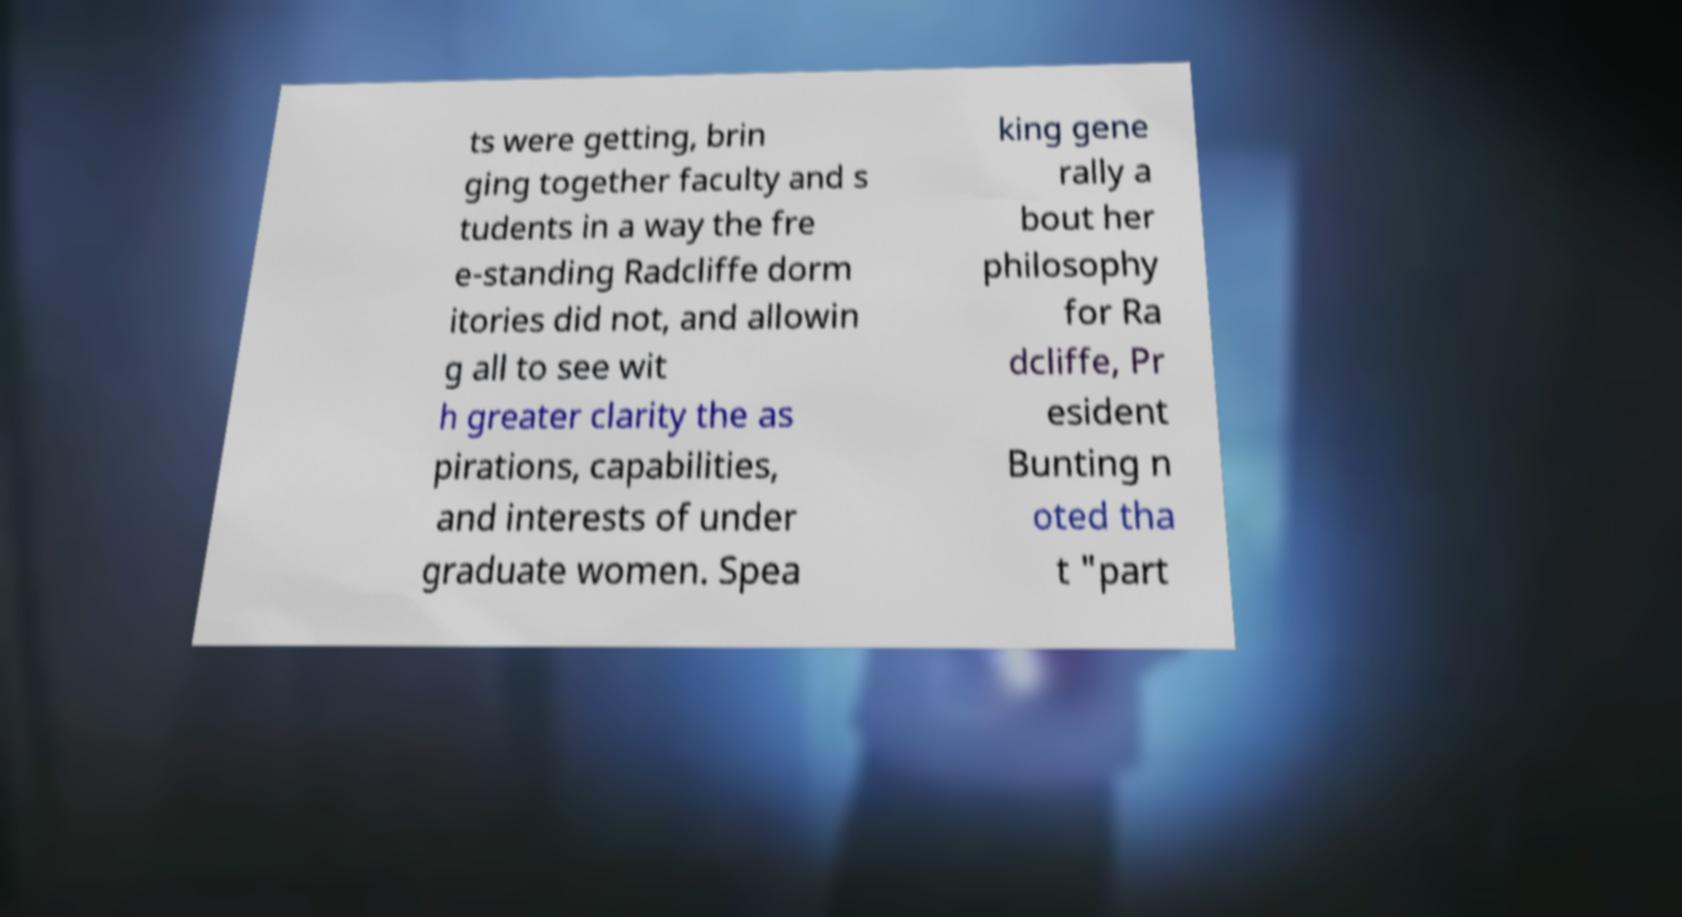There's text embedded in this image that I need extracted. Can you transcribe it verbatim? ts were getting, brin ging together faculty and s tudents in a way the fre e-standing Radcliffe dorm itories did not, and allowin g all to see wit h greater clarity the as pirations, capabilities, and interests of under graduate women. Spea king gene rally a bout her philosophy for Ra dcliffe, Pr esident Bunting n oted tha t "part 